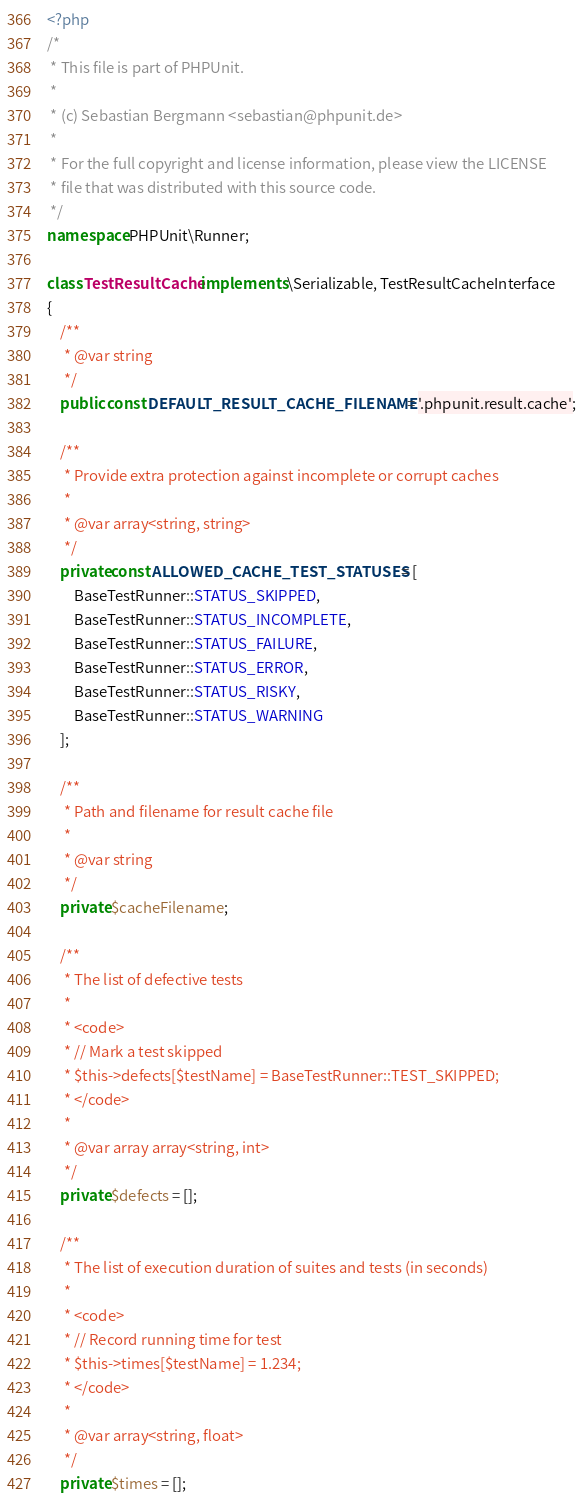Convert code to text. <code><loc_0><loc_0><loc_500><loc_500><_PHP_><?php
/*
 * This file is part of PHPUnit.
 *
 * (c) Sebastian Bergmann <sebastian@phpunit.de>
 *
 * For the full copyright and license information, please view the LICENSE
 * file that was distributed with this source code.
 */
namespace PHPUnit\Runner;

class TestResultCache implements \Serializable, TestResultCacheInterface
{
    /**
     * @var string
     */
    public const DEFAULT_RESULT_CACHE_FILENAME = '.phpunit.result.cache';

    /**
     * Provide extra protection against incomplete or corrupt caches
     *
     * @var array<string, string>
     */
    private const ALLOWED_CACHE_TEST_STATUSES = [
        BaseTestRunner::STATUS_SKIPPED,
        BaseTestRunner::STATUS_INCOMPLETE,
        BaseTestRunner::STATUS_FAILURE,
        BaseTestRunner::STATUS_ERROR,
        BaseTestRunner::STATUS_RISKY,
        BaseTestRunner::STATUS_WARNING
    ];

    /**
     * Path and filename for result cache file
     *
     * @var string
     */
    private $cacheFilename;

    /**
     * The list of defective tests
     *
     * <code>
     * // Mark a test skipped
     * $this->defects[$testName] = BaseTestRunner::TEST_SKIPPED;
     * </code>
     *
     * @var array array<string, int>
     */
    private $defects = [];

    /**
     * The list of execution duration of suites and tests (in seconds)
     *
     * <code>
     * // Record running time for test
     * $this->times[$testName] = 1.234;
     * </code>
     *
     * @var array<string, float>
     */
    private $times = [];
</code> 